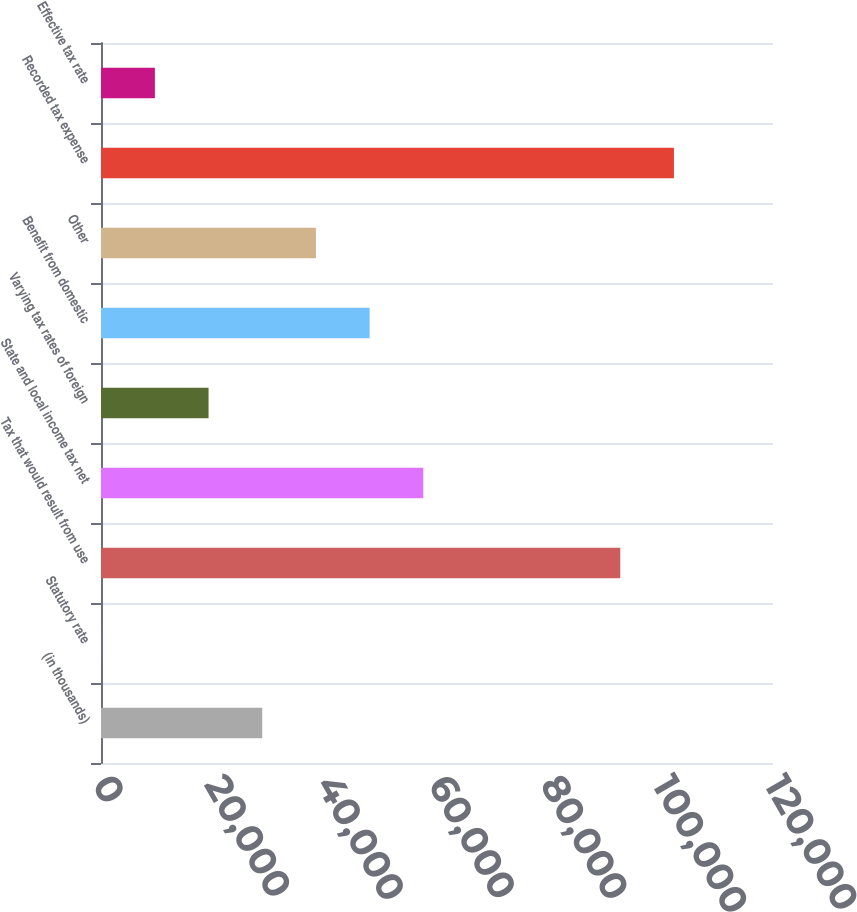Convert chart. <chart><loc_0><loc_0><loc_500><loc_500><bar_chart><fcel>(in thousands)<fcel>Statutory rate<fcel>Tax that would result from use<fcel>State and local income tax net<fcel>Varying tax rates of foreign<fcel>Benefit from domestic<fcel>Other<fcel>Recorded tax expense<fcel>Effective tax rate<nl><fcel>28794.5<fcel>35<fcel>92726<fcel>57554<fcel>19208<fcel>47967.5<fcel>38381<fcel>102312<fcel>9621.5<nl></chart> 